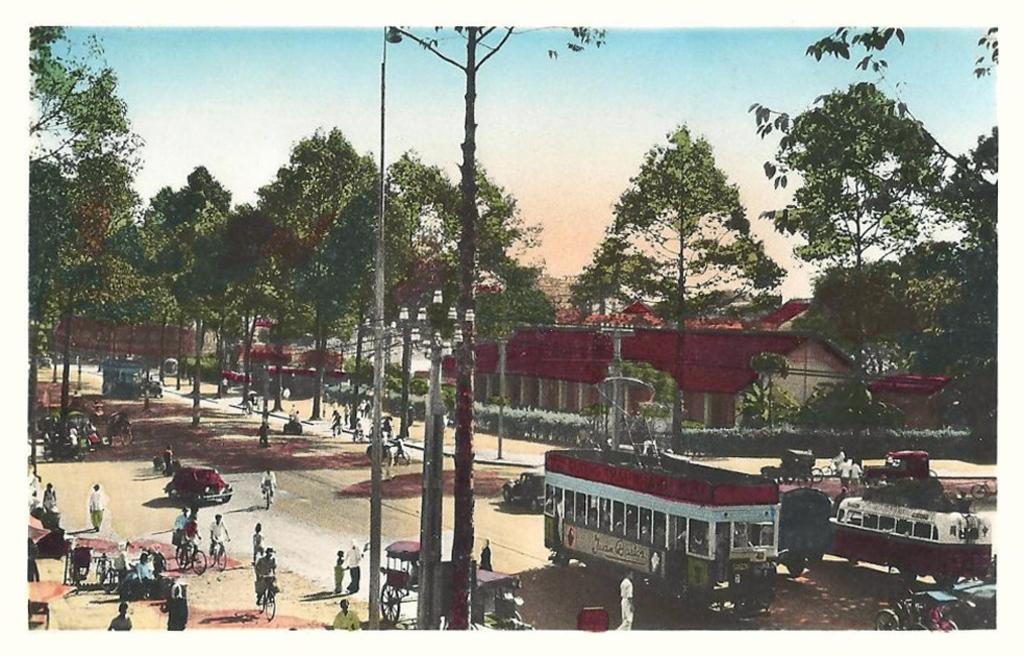What can be seen on the road in the image? There are vehicles on the road in the image. Who or what else is present in the image besides the vehicles? There is a group of people and plants in the image. What type of structures can be seen in the image? There are houses in the image. What is visible in the background of the image? The sky is visible in the background of the image. What other natural elements are present in the image? There are trees in the image. What type of monkey can be heard making a voice in the image? There is no monkey present in the image, and therefore no such voice can be heard. What type of approval is given by the group of people in the image? There is no indication of approval or disapproval in the image; it simply shows a group of people, vehicles, plants, trees, houses, and the sky. 